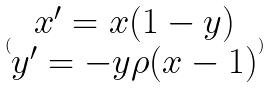<formula> <loc_0><loc_0><loc_500><loc_500>( \begin{matrix} x ^ { \prime } = x ( 1 - y ) \\ y ^ { \prime } = - y \rho ( x - 1 ) \end{matrix} )</formula> 